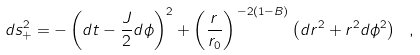Convert formula to latex. <formula><loc_0><loc_0><loc_500><loc_500>d s _ { + } ^ { 2 } = - \left ( d t - \frac { J } { 2 } d \phi \right ) ^ { 2 } + \left ( \frac { r } { r _ { 0 } } \right ) ^ { \, - 2 ( 1 - B ) } \left ( d r ^ { 2 } + r ^ { 2 } d \phi ^ { 2 } \right ) \ ,</formula> 